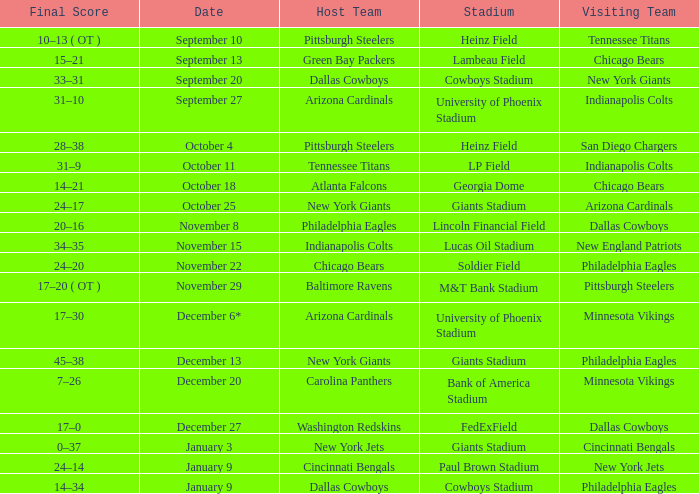Tell me the visiting team for october 4 San Diego Chargers. 